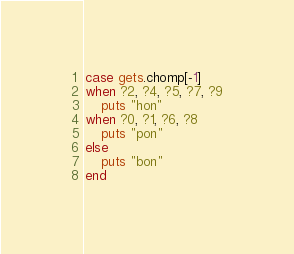<code> <loc_0><loc_0><loc_500><loc_500><_Ruby_>case gets.chomp[-1]
when ?2, ?4, ?5, ?7, ?9
    puts "hon"
when ?0, ?1, ?6, ?8
    puts "pon"
else
    puts "bon"
end</code> 